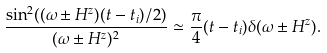<formula> <loc_0><loc_0><loc_500><loc_500>\frac { \sin ^ { 2 } ( ( \omega \pm H ^ { z } ) ( t - t _ { i } ) / 2 ) } { ( \omega \pm H ^ { z } ) ^ { 2 } } \simeq \frac { \pi } { 4 } ( t - t _ { i } ) \delta ( \omega \pm H ^ { z } ) .</formula> 